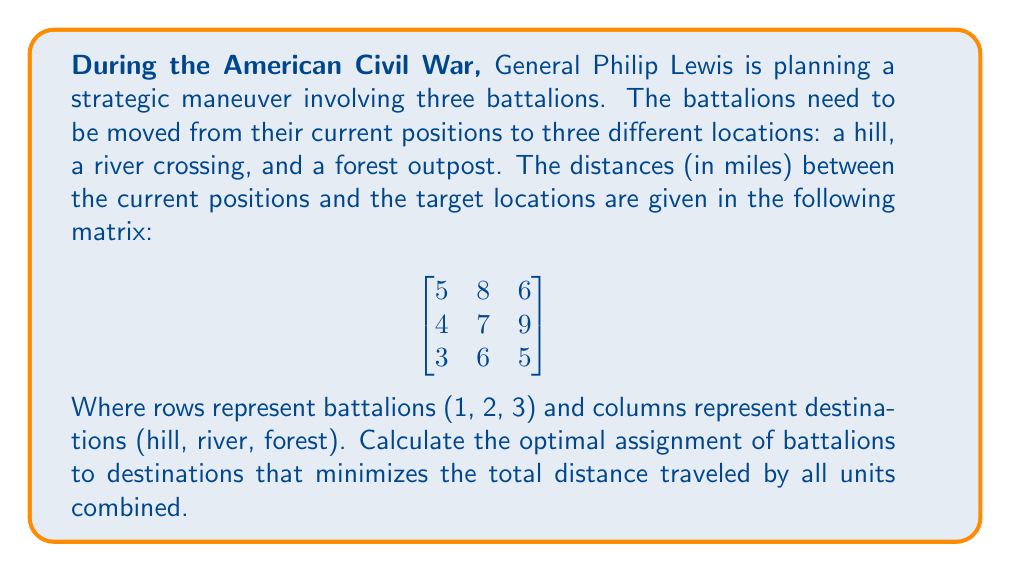What is the answer to this math problem? To solve this optimization problem, we can use the Hungarian algorithm, also known as the Munkres algorithm. However, for this 3x3 matrix, we can also solve it by enumeration. Let's go through the steps:

1. List all possible assignments:
   There are 3! = 6 possible assignments.

2. Calculate the total distance for each assignment:
   a) 1-hill, 2-river, 3-forest: 5 + 7 + 5 = 17
   b) 1-hill, 2-forest, 3-river: 5 + 9 + 6 = 20
   c) 1-river, 2-hill, 3-forest: 8 + 4 + 5 = 17
   d) 1-river, 2-forest, 3-hill: 8 + 9 + 3 = 20
   e) 1-forest, 2-hill, 3-river: 6 + 4 + 6 = 16
   f) 1-forest, 2-river, 3-hill: 6 + 7 + 3 = 16

3. Identify the minimum total distance:
   The minimum total distance is 16 miles, which occurs in two assignments:
   e) 1-forest, 2-hill, 3-river
   f) 1-forest, 2-river, 3-hill

Both of these assignments are optimal solutions, as they both result in the minimum total distance of 16 miles.
Answer: The optimal assignment that minimizes the total distance traveled is either:
1. Battalion 1 to forest, Battalion 2 to hill, Battalion 3 to river
OR
2. Battalion 1 to forest, Battalion 2 to river, Battalion 3 to hill

Both assignments result in a total distance of 16 miles. 